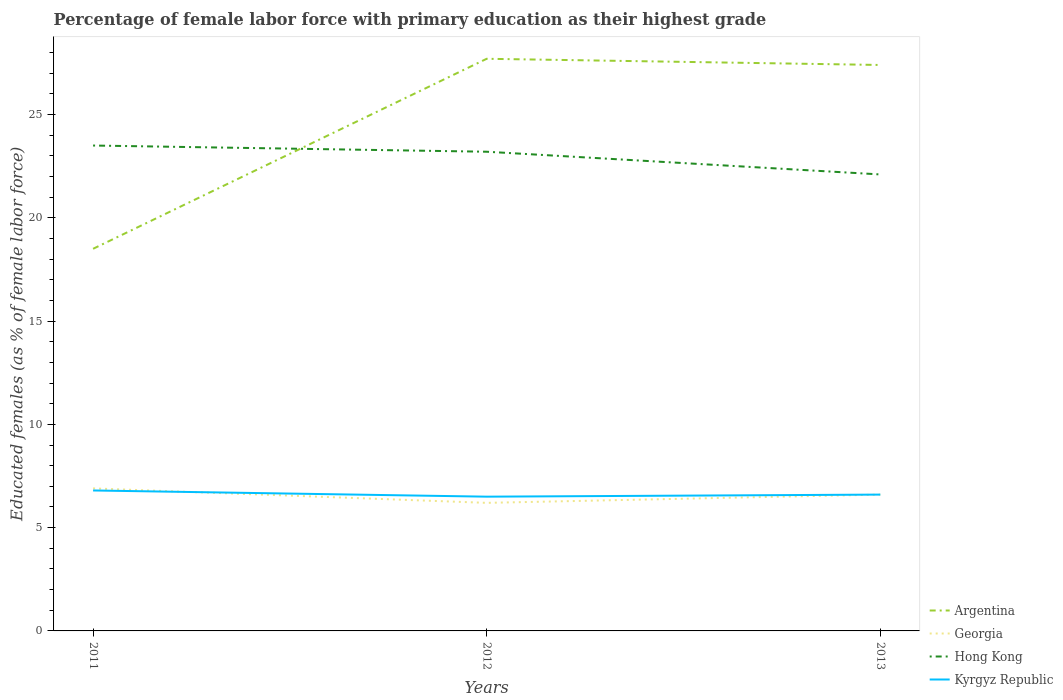How many different coloured lines are there?
Your response must be concise. 4. Does the line corresponding to Kyrgyz Republic intersect with the line corresponding to Hong Kong?
Provide a short and direct response. No. Across all years, what is the maximum percentage of female labor force with primary education in Georgia?
Offer a terse response. 6.2. In which year was the percentage of female labor force with primary education in Argentina maximum?
Provide a short and direct response. 2011. What is the total percentage of female labor force with primary education in Hong Kong in the graph?
Provide a succinct answer. 1.1. What is the difference between the highest and the second highest percentage of female labor force with primary education in Kyrgyz Republic?
Provide a succinct answer. 0.3. What is the difference between the highest and the lowest percentage of female labor force with primary education in Kyrgyz Republic?
Keep it short and to the point. 1. How many lines are there?
Keep it short and to the point. 4. How many years are there in the graph?
Offer a very short reply. 3. What is the difference between two consecutive major ticks on the Y-axis?
Your answer should be compact. 5. Does the graph contain any zero values?
Provide a succinct answer. No. Does the graph contain grids?
Your response must be concise. No. Where does the legend appear in the graph?
Keep it short and to the point. Bottom right. What is the title of the graph?
Provide a succinct answer. Percentage of female labor force with primary education as their highest grade. Does "High income" appear as one of the legend labels in the graph?
Your response must be concise. No. What is the label or title of the X-axis?
Your answer should be very brief. Years. What is the label or title of the Y-axis?
Offer a very short reply. Educated females (as % of female labor force). What is the Educated females (as % of female labor force) of Argentina in 2011?
Give a very brief answer. 18.5. What is the Educated females (as % of female labor force) of Georgia in 2011?
Provide a short and direct response. 6.9. What is the Educated females (as % of female labor force) of Kyrgyz Republic in 2011?
Ensure brevity in your answer.  6.8. What is the Educated females (as % of female labor force) in Argentina in 2012?
Your answer should be very brief. 27.7. What is the Educated females (as % of female labor force) of Georgia in 2012?
Keep it short and to the point. 6.2. What is the Educated females (as % of female labor force) of Hong Kong in 2012?
Your response must be concise. 23.2. What is the Educated females (as % of female labor force) in Kyrgyz Republic in 2012?
Provide a succinct answer. 6.5. What is the Educated females (as % of female labor force) in Argentina in 2013?
Offer a very short reply. 27.4. What is the Educated females (as % of female labor force) of Georgia in 2013?
Keep it short and to the point. 6.6. What is the Educated females (as % of female labor force) in Hong Kong in 2013?
Offer a terse response. 22.1. What is the Educated females (as % of female labor force) of Kyrgyz Republic in 2013?
Give a very brief answer. 6.6. Across all years, what is the maximum Educated females (as % of female labor force) of Argentina?
Ensure brevity in your answer.  27.7. Across all years, what is the maximum Educated females (as % of female labor force) in Georgia?
Your response must be concise. 6.9. Across all years, what is the maximum Educated females (as % of female labor force) in Hong Kong?
Provide a succinct answer. 23.5. Across all years, what is the maximum Educated females (as % of female labor force) in Kyrgyz Republic?
Your answer should be very brief. 6.8. Across all years, what is the minimum Educated females (as % of female labor force) of Georgia?
Provide a short and direct response. 6.2. Across all years, what is the minimum Educated females (as % of female labor force) of Hong Kong?
Provide a short and direct response. 22.1. Across all years, what is the minimum Educated females (as % of female labor force) of Kyrgyz Republic?
Your answer should be compact. 6.5. What is the total Educated females (as % of female labor force) of Argentina in the graph?
Make the answer very short. 73.6. What is the total Educated females (as % of female labor force) in Georgia in the graph?
Give a very brief answer. 19.7. What is the total Educated females (as % of female labor force) of Hong Kong in the graph?
Your response must be concise. 68.8. What is the total Educated females (as % of female labor force) of Kyrgyz Republic in the graph?
Your answer should be compact. 19.9. What is the difference between the Educated females (as % of female labor force) of Argentina in 2011 and that in 2012?
Your answer should be very brief. -9.2. What is the difference between the Educated females (as % of female labor force) in Hong Kong in 2011 and that in 2012?
Keep it short and to the point. 0.3. What is the difference between the Educated females (as % of female labor force) of Kyrgyz Republic in 2011 and that in 2012?
Your answer should be very brief. 0.3. What is the difference between the Educated females (as % of female labor force) in Argentina in 2011 and that in 2013?
Give a very brief answer. -8.9. What is the difference between the Educated females (as % of female labor force) of Georgia in 2012 and that in 2013?
Offer a very short reply. -0.4. What is the difference between the Educated females (as % of female labor force) in Hong Kong in 2012 and that in 2013?
Keep it short and to the point. 1.1. What is the difference between the Educated females (as % of female labor force) in Georgia in 2011 and the Educated females (as % of female labor force) in Hong Kong in 2012?
Provide a short and direct response. -16.3. What is the difference between the Educated females (as % of female labor force) of Argentina in 2011 and the Educated females (as % of female labor force) of Kyrgyz Republic in 2013?
Provide a succinct answer. 11.9. What is the difference between the Educated females (as % of female labor force) in Georgia in 2011 and the Educated females (as % of female labor force) in Hong Kong in 2013?
Keep it short and to the point. -15.2. What is the difference between the Educated females (as % of female labor force) in Georgia in 2011 and the Educated females (as % of female labor force) in Kyrgyz Republic in 2013?
Your answer should be compact. 0.3. What is the difference between the Educated females (as % of female labor force) of Argentina in 2012 and the Educated females (as % of female labor force) of Georgia in 2013?
Your answer should be very brief. 21.1. What is the difference between the Educated females (as % of female labor force) of Argentina in 2012 and the Educated females (as % of female labor force) of Kyrgyz Republic in 2013?
Your response must be concise. 21.1. What is the difference between the Educated females (as % of female labor force) in Georgia in 2012 and the Educated females (as % of female labor force) in Hong Kong in 2013?
Make the answer very short. -15.9. What is the average Educated females (as % of female labor force) of Argentina per year?
Offer a terse response. 24.53. What is the average Educated females (as % of female labor force) in Georgia per year?
Ensure brevity in your answer.  6.57. What is the average Educated females (as % of female labor force) of Hong Kong per year?
Provide a succinct answer. 22.93. What is the average Educated females (as % of female labor force) of Kyrgyz Republic per year?
Your answer should be very brief. 6.63. In the year 2011, what is the difference between the Educated females (as % of female labor force) of Argentina and Educated females (as % of female labor force) of Kyrgyz Republic?
Give a very brief answer. 11.7. In the year 2011, what is the difference between the Educated females (as % of female labor force) of Georgia and Educated females (as % of female labor force) of Hong Kong?
Keep it short and to the point. -16.6. In the year 2012, what is the difference between the Educated females (as % of female labor force) in Argentina and Educated females (as % of female labor force) in Georgia?
Provide a short and direct response. 21.5. In the year 2012, what is the difference between the Educated females (as % of female labor force) in Argentina and Educated females (as % of female labor force) in Hong Kong?
Make the answer very short. 4.5. In the year 2012, what is the difference between the Educated females (as % of female labor force) of Argentina and Educated females (as % of female labor force) of Kyrgyz Republic?
Your answer should be compact. 21.2. In the year 2012, what is the difference between the Educated females (as % of female labor force) in Hong Kong and Educated females (as % of female labor force) in Kyrgyz Republic?
Offer a very short reply. 16.7. In the year 2013, what is the difference between the Educated females (as % of female labor force) of Argentina and Educated females (as % of female labor force) of Georgia?
Provide a succinct answer. 20.8. In the year 2013, what is the difference between the Educated females (as % of female labor force) in Argentina and Educated females (as % of female labor force) in Hong Kong?
Your response must be concise. 5.3. In the year 2013, what is the difference between the Educated females (as % of female labor force) in Argentina and Educated females (as % of female labor force) in Kyrgyz Republic?
Your answer should be very brief. 20.8. In the year 2013, what is the difference between the Educated females (as % of female labor force) of Georgia and Educated females (as % of female labor force) of Hong Kong?
Keep it short and to the point. -15.5. In the year 2013, what is the difference between the Educated females (as % of female labor force) in Georgia and Educated females (as % of female labor force) in Kyrgyz Republic?
Provide a short and direct response. 0. What is the ratio of the Educated females (as % of female labor force) in Argentina in 2011 to that in 2012?
Offer a terse response. 0.67. What is the ratio of the Educated females (as % of female labor force) in Georgia in 2011 to that in 2012?
Give a very brief answer. 1.11. What is the ratio of the Educated females (as % of female labor force) of Hong Kong in 2011 to that in 2012?
Your response must be concise. 1.01. What is the ratio of the Educated females (as % of female labor force) in Kyrgyz Republic in 2011 to that in 2012?
Provide a short and direct response. 1.05. What is the ratio of the Educated females (as % of female labor force) of Argentina in 2011 to that in 2013?
Keep it short and to the point. 0.68. What is the ratio of the Educated females (as % of female labor force) in Georgia in 2011 to that in 2013?
Make the answer very short. 1.05. What is the ratio of the Educated females (as % of female labor force) in Hong Kong in 2011 to that in 2013?
Your answer should be very brief. 1.06. What is the ratio of the Educated females (as % of female labor force) in Kyrgyz Republic in 2011 to that in 2013?
Your answer should be compact. 1.03. What is the ratio of the Educated females (as % of female labor force) in Argentina in 2012 to that in 2013?
Offer a very short reply. 1.01. What is the ratio of the Educated females (as % of female labor force) in Georgia in 2012 to that in 2013?
Make the answer very short. 0.94. What is the ratio of the Educated females (as % of female labor force) of Hong Kong in 2012 to that in 2013?
Your response must be concise. 1.05. What is the difference between the highest and the second highest Educated females (as % of female labor force) in Argentina?
Give a very brief answer. 0.3. What is the difference between the highest and the second highest Educated females (as % of female labor force) of Georgia?
Your answer should be very brief. 0.3. What is the difference between the highest and the second highest Educated females (as % of female labor force) of Hong Kong?
Offer a terse response. 0.3. What is the difference between the highest and the lowest Educated females (as % of female labor force) of Argentina?
Provide a succinct answer. 9.2. What is the difference between the highest and the lowest Educated females (as % of female labor force) in Hong Kong?
Your response must be concise. 1.4. What is the difference between the highest and the lowest Educated females (as % of female labor force) in Kyrgyz Republic?
Your answer should be very brief. 0.3. 